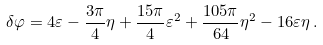<formula> <loc_0><loc_0><loc_500><loc_500>\delta \varphi = 4 \varepsilon - \frac { 3 \pi } { 4 } \eta + \frac { 1 5 \pi } { 4 } \varepsilon ^ { 2 } + \frac { 1 0 5 \pi } { 6 4 } \eta ^ { 2 } - 1 6 \varepsilon \eta \, .</formula> 